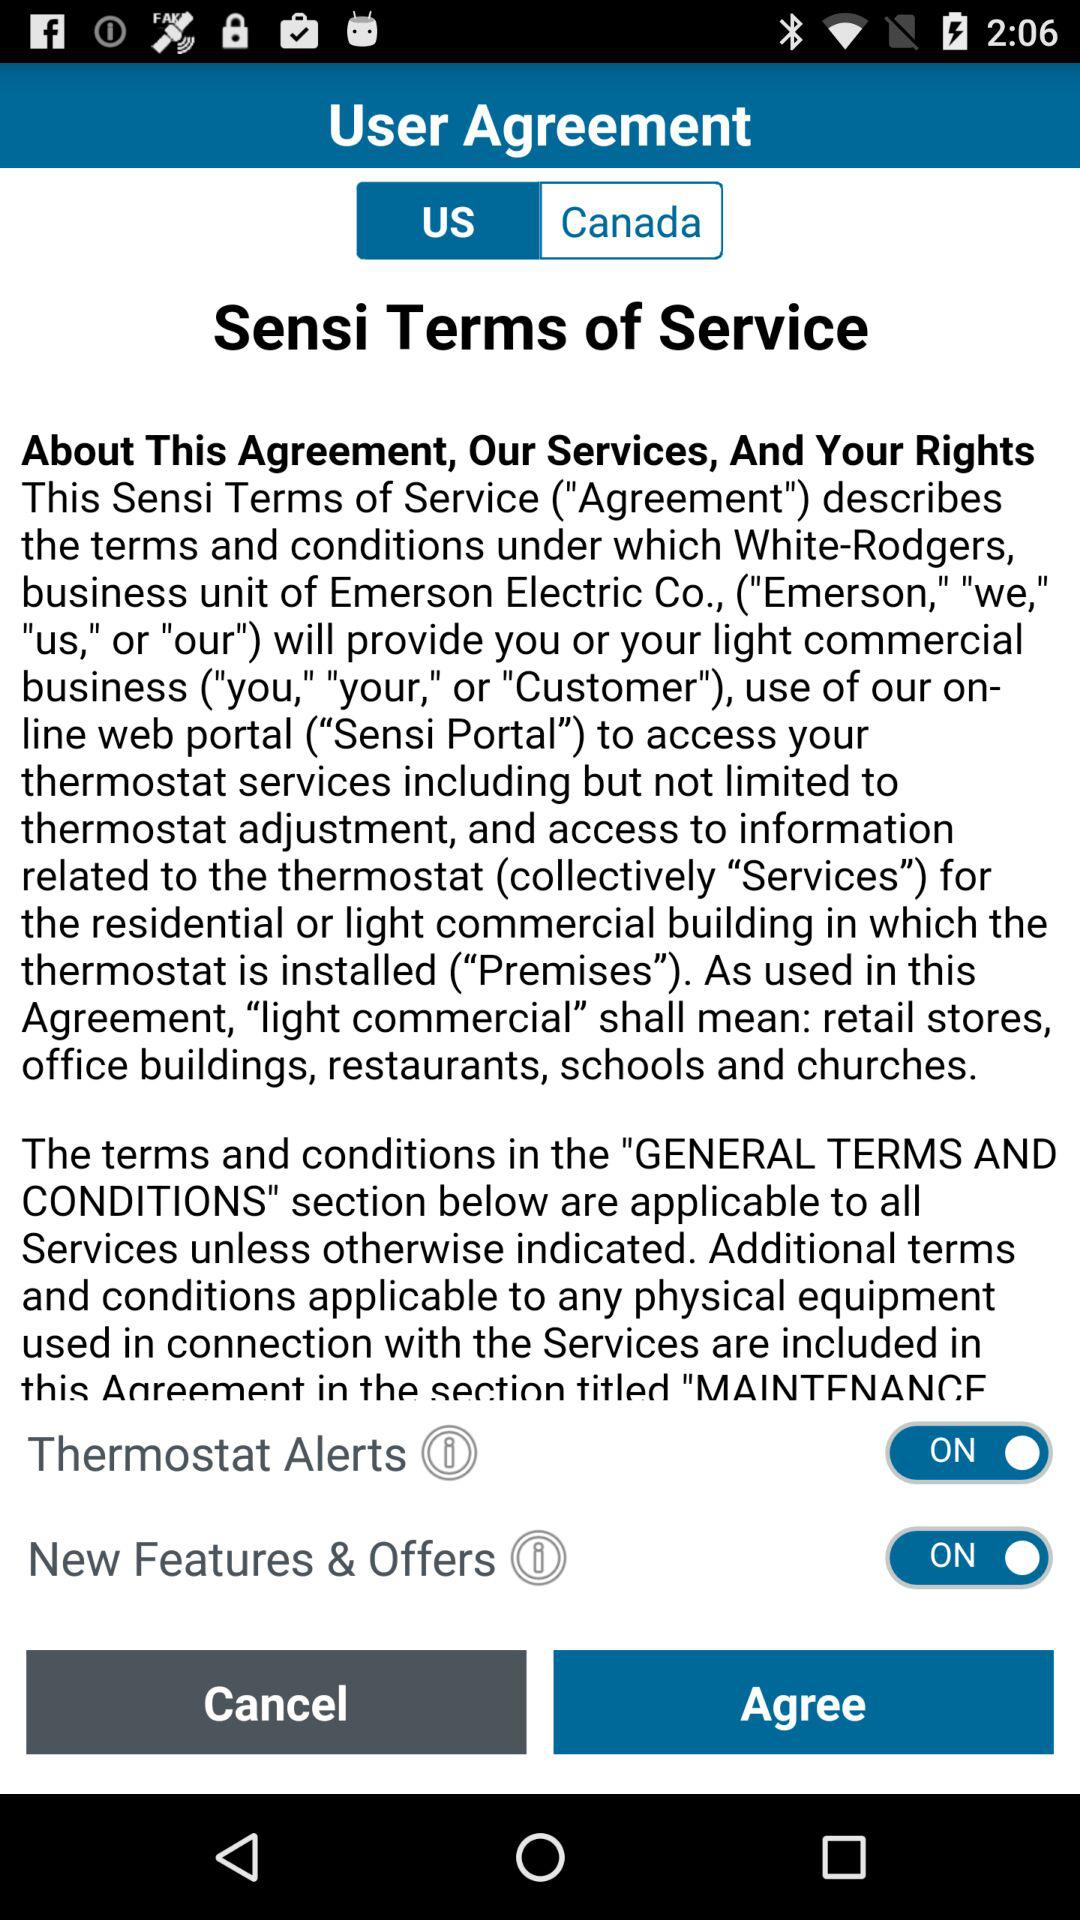Is "Thermostat Alerts" enabled or disabled? The "Thermostat Alerts" is on. 